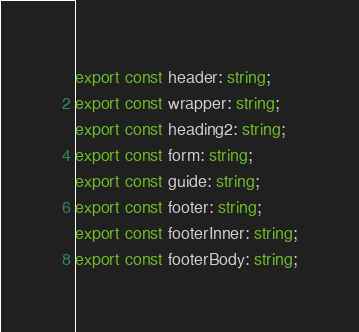Convert code to text. <code><loc_0><loc_0><loc_500><loc_500><_TypeScript_>export const header: string;
export const wrapper: string;
export const heading2: string;
export const form: string;
export const guide: string;
export const footer: string;
export const footerInner: string;
export const footerBody: string;
</code> 